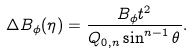<formula> <loc_0><loc_0><loc_500><loc_500>\Delta B _ { \phi } ( \eta ) = \frac { B _ { \phi } t ^ { 2 } } { Q _ { 0 , n } \sin ^ { n - 1 } \theta } .</formula> 